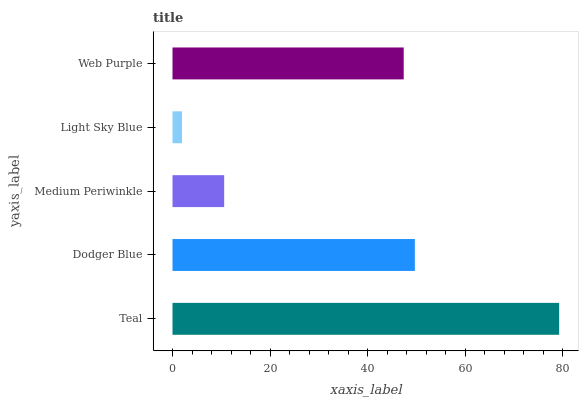Is Light Sky Blue the minimum?
Answer yes or no. Yes. Is Teal the maximum?
Answer yes or no. Yes. Is Dodger Blue the minimum?
Answer yes or no. No. Is Dodger Blue the maximum?
Answer yes or no. No. Is Teal greater than Dodger Blue?
Answer yes or no. Yes. Is Dodger Blue less than Teal?
Answer yes or no. Yes. Is Dodger Blue greater than Teal?
Answer yes or no. No. Is Teal less than Dodger Blue?
Answer yes or no. No. Is Web Purple the high median?
Answer yes or no. Yes. Is Web Purple the low median?
Answer yes or no. Yes. Is Teal the high median?
Answer yes or no. No. Is Light Sky Blue the low median?
Answer yes or no. No. 